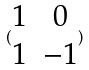<formula> <loc_0><loc_0><loc_500><loc_500>( \begin{matrix} 1 & 0 \\ 1 & - 1 \end{matrix} )</formula> 